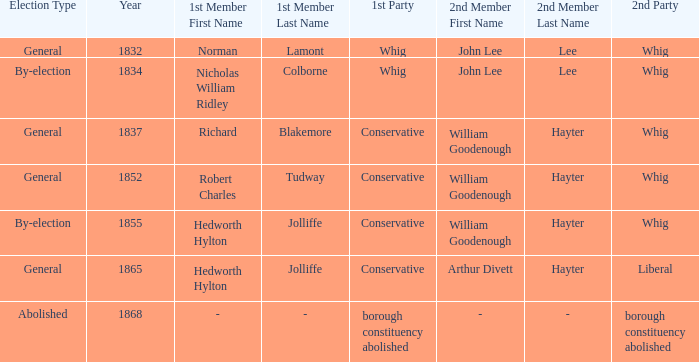What election has a 1st member of richard blakemore and a 2nd member of william goodenough hayter? 1837.0. 